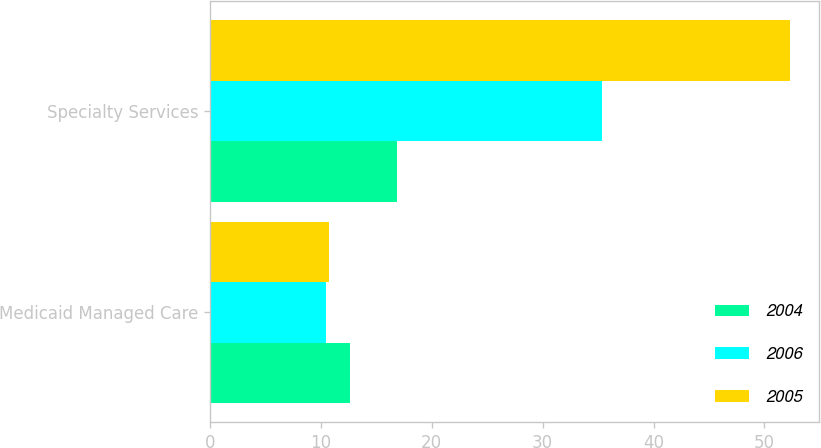Convert chart to OTSL. <chart><loc_0><loc_0><loc_500><loc_500><stacked_bar_chart><ecel><fcel>Medicaid Managed Care<fcel>Specialty Services<nl><fcel>2004<fcel>12.6<fcel>16.9<nl><fcel>2006<fcel>10.5<fcel>35.4<nl><fcel>2005<fcel>10.7<fcel>52.3<nl></chart> 